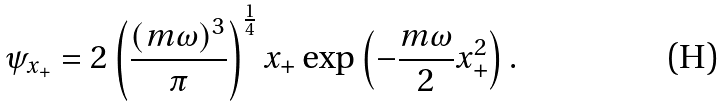Convert formula to latex. <formula><loc_0><loc_0><loc_500><loc_500>\psi _ { x _ { + } } = 2 \left ( \frac { ( m \omega ) ^ { 3 } } { \pi } \right ) ^ { \frac { 1 } { 4 } } x _ { + } \exp \left ( - \frac { m \omega } { 2 } x ^ { 2 } _ { + } \right ) .</formula> 